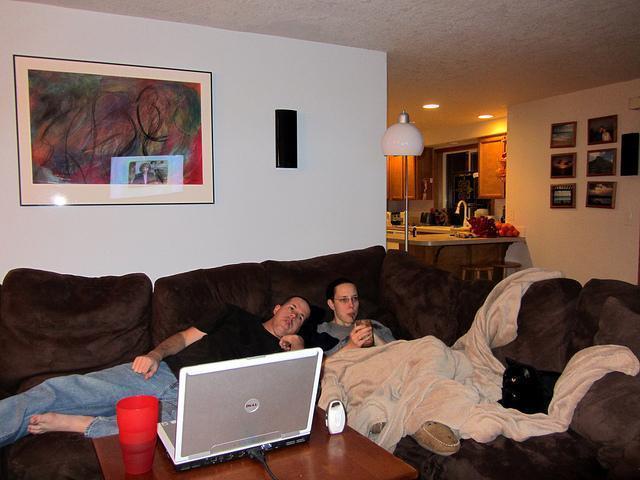How many people are visible?
Give a very brief answer. 2. 